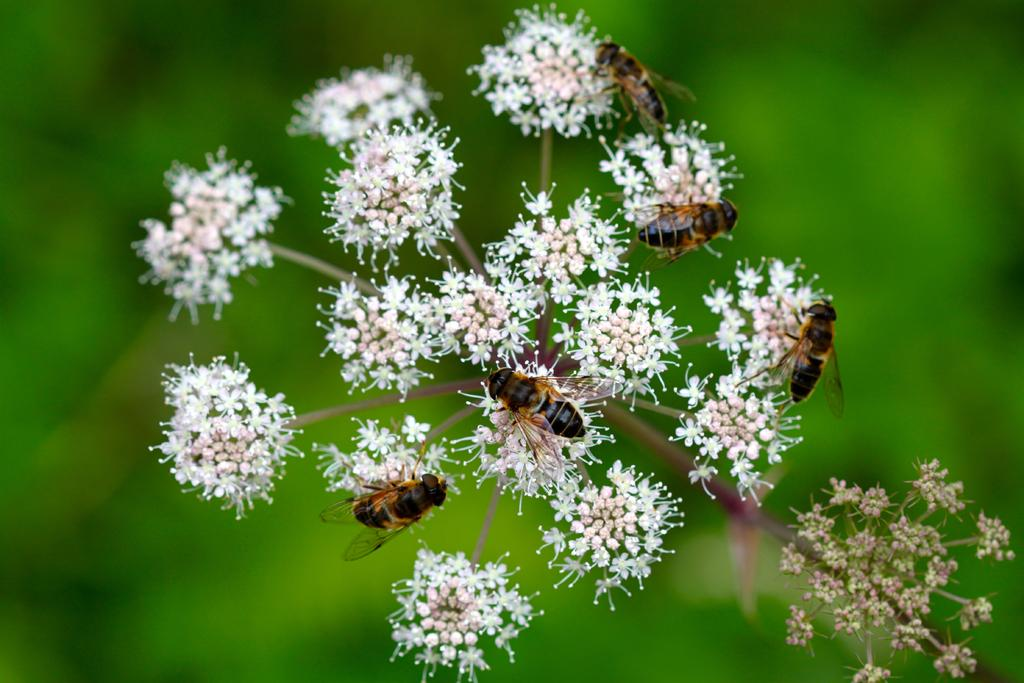What type of creatures can be seen in the image? There are insects in the image. Where are the insects located? The insects are on a flower. What type of horn is present on the turkey in the image? There is no turkey or horn present in the image; it features insects on a flower. 